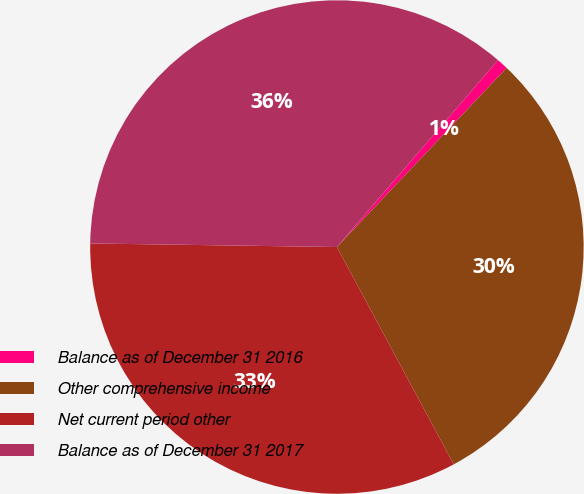Convert chart to OTSL. <chart><loc_0><loc_0><loc_500><loc_500><pie_chart><fcel>Balance as of December 31 2016<fcel>Other comprehensive income<fcel>Net current period other<fcel>Balance as of December 31 2017<nl><fcel>0.75%<fcel>30.08%<fcel>33.08%<fcel>36.09%<nl></chart> 